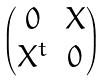<formula> <loc_0><loc_0><loc_500><loc_500>\begin{pmatrix} 0 & X \\ X ^ { t } & 0 \end{pmatrix}</formula> 